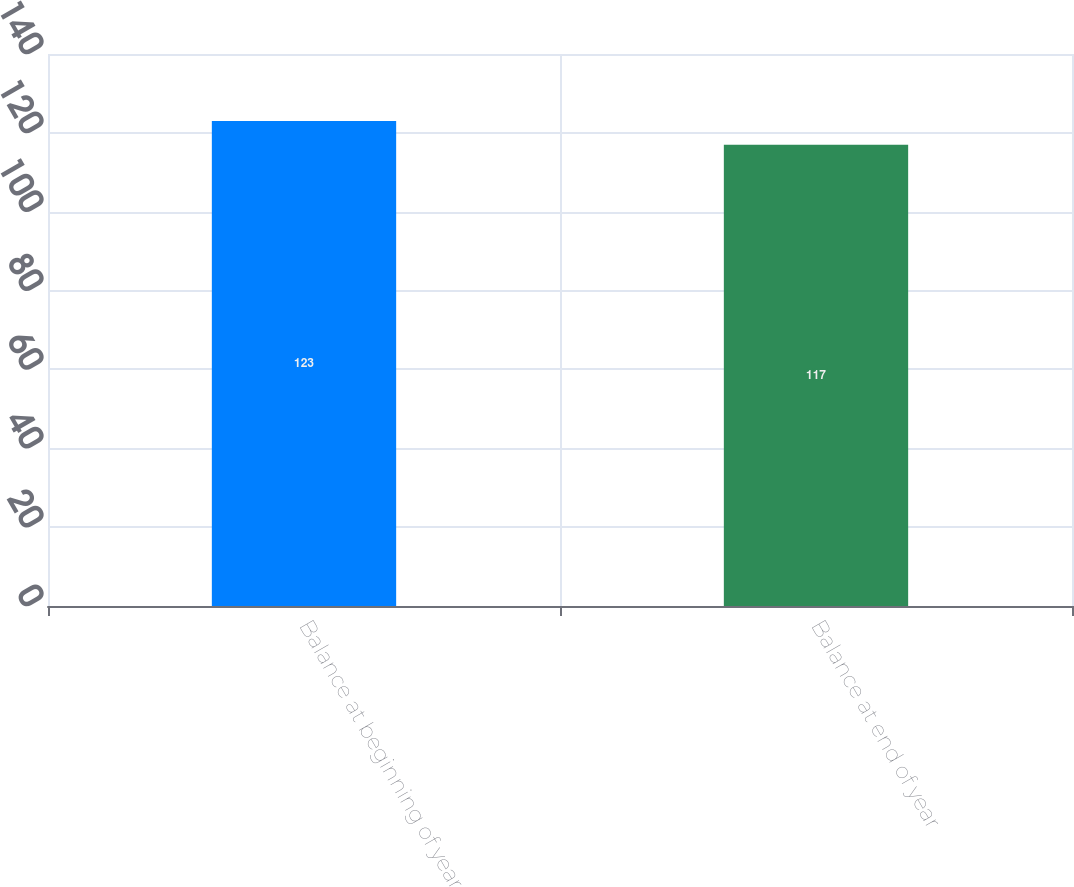Convert chart. <chart><loc_0><loc_0><loc_500><loc_500><bar_chart><fcel>Balance at beginning of year<fcel>Balance at end of year<nl><fcel>123<fcel>117<nl></chart> 